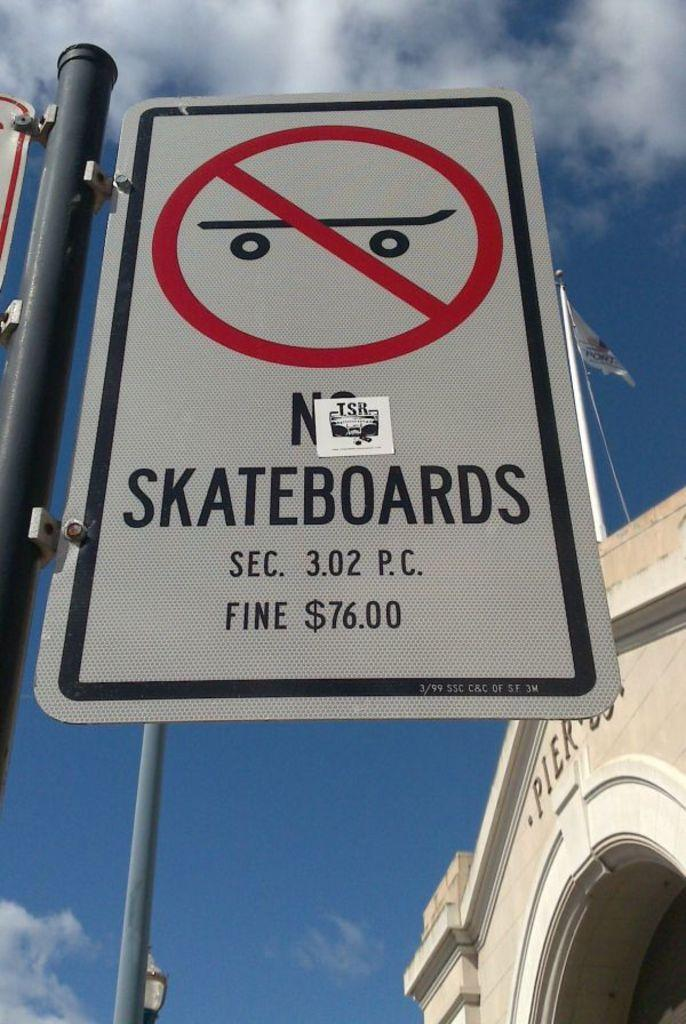<image>
Present a compact description of the photo's key features. A sign that says no skateboards with a fine of 76 dollars. 